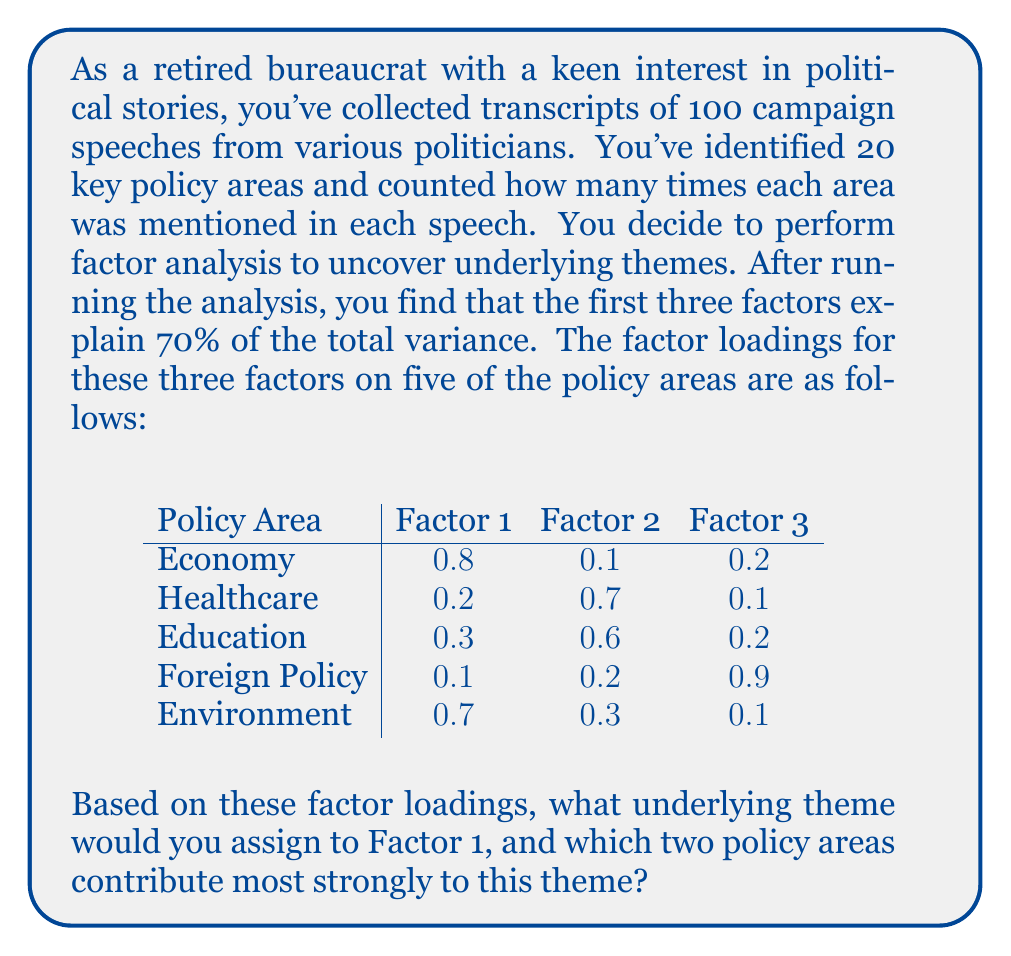What is the answer to this math problem? To interpret the factors and assign themes, we need to examine the factor loadings for each policy area:

1. Factor analysis aims to identify underlying latent variables (factors) that explain the correlations among observed variables.

2. Factor loadings represent the correlation between each observed variable and the latent factor. Higher absolute values indicate stronger relationships.

3. To interpret a factor, we look for variables with high loadings (typically > 0.5) on that factor.

4. For Factor 1:
   - Economy: 0.8
   - Healthcare: 0.2
   - Education: 0.3
   - Foreign Policy: 0.1
   - Environment: 0.7

5. The two highest loadings for Factor 1 are:
   - Economy (0.8)
   - Environment (0.7)

6. Both of these loadings are > 0.5, indicating strong relationships with Factor 1.

7. Given your background in political analysis, you might recognize that economic and environmental issues are often closely related in political discourse. For example, discussions about job creation, economic growth, and environmental regulations frequently overlap.

8. A suitable theme for Factor 1 could be "Sustainable Economic Development" or "Green Economy," as it captures the strong association between economic and environmental topics in the speeches analyzed.

This interpretation aligns with your experience in analyzing political narratives, where you've likely observed the increasing importance of balancing economic growth with environmental concerns in modern political discourse.
Answer: Theme for Factor 1: Sustainable Economic Development

Policy areas contributing most strongly:
1. Economy
2. Environment 